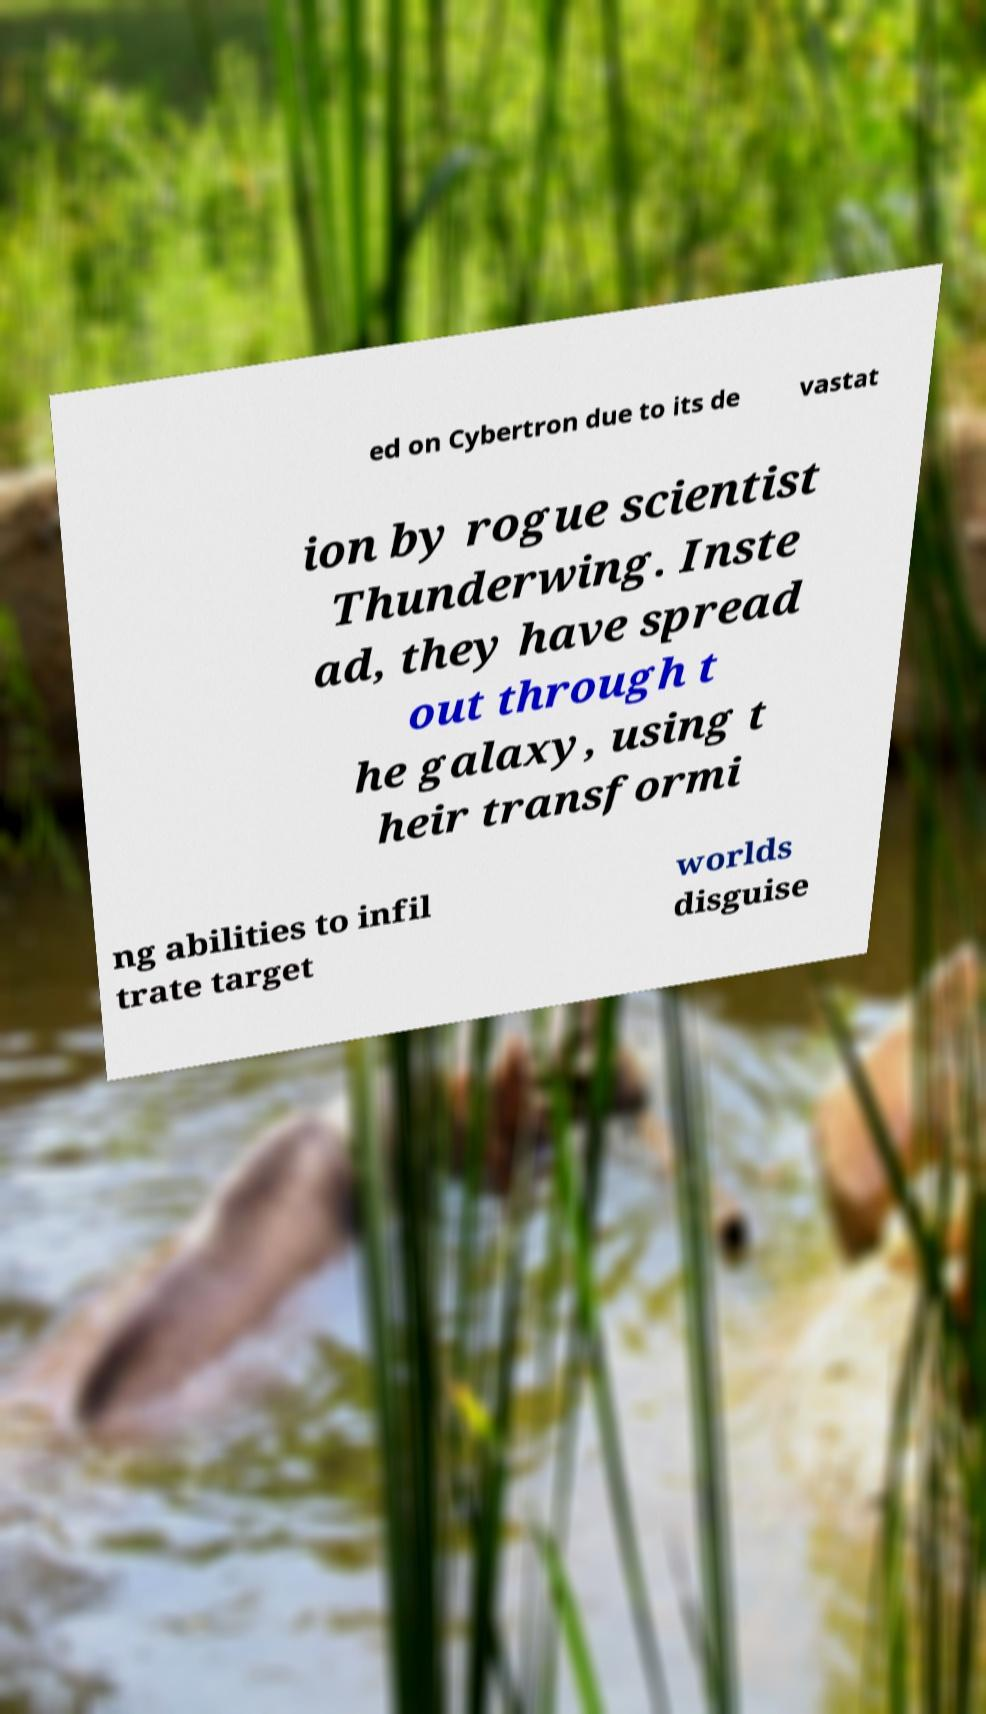What messages or text are displayed in this image? I need them in a readable, typed format. ed on Cybertron due to its de vastat ion by rogue scientist Thunderwing. Inste ad, they have spread out through t he galaxy, using t heir transformi ng abilities to infil trate target worlds disguise 